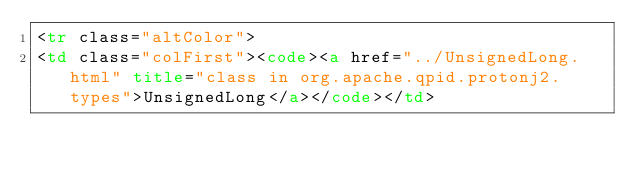<code> <loc_0><loc_0><loc_500><loc_500><_HTML_><tr class="altColor">
<td class="colFirst"><code><a href="../UnsignedLong.html" title="class in org.apache.qpid.protonj2.types">UnsignedLong</a></code></td></code> 